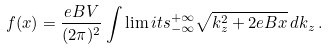Convert formula to latex. <formula><loc_0><loc_0><loc_500><loc_500>f ( x ) = \frac { e B V } { ( 2 \pi ) ^ { 2 } } \int \lim i t s _ { - \infty } ^ { + \infty } \sqrt { k _ { z } ^ { 2 } + 2 e B x } \, d k _ { z } \, .</formula> 